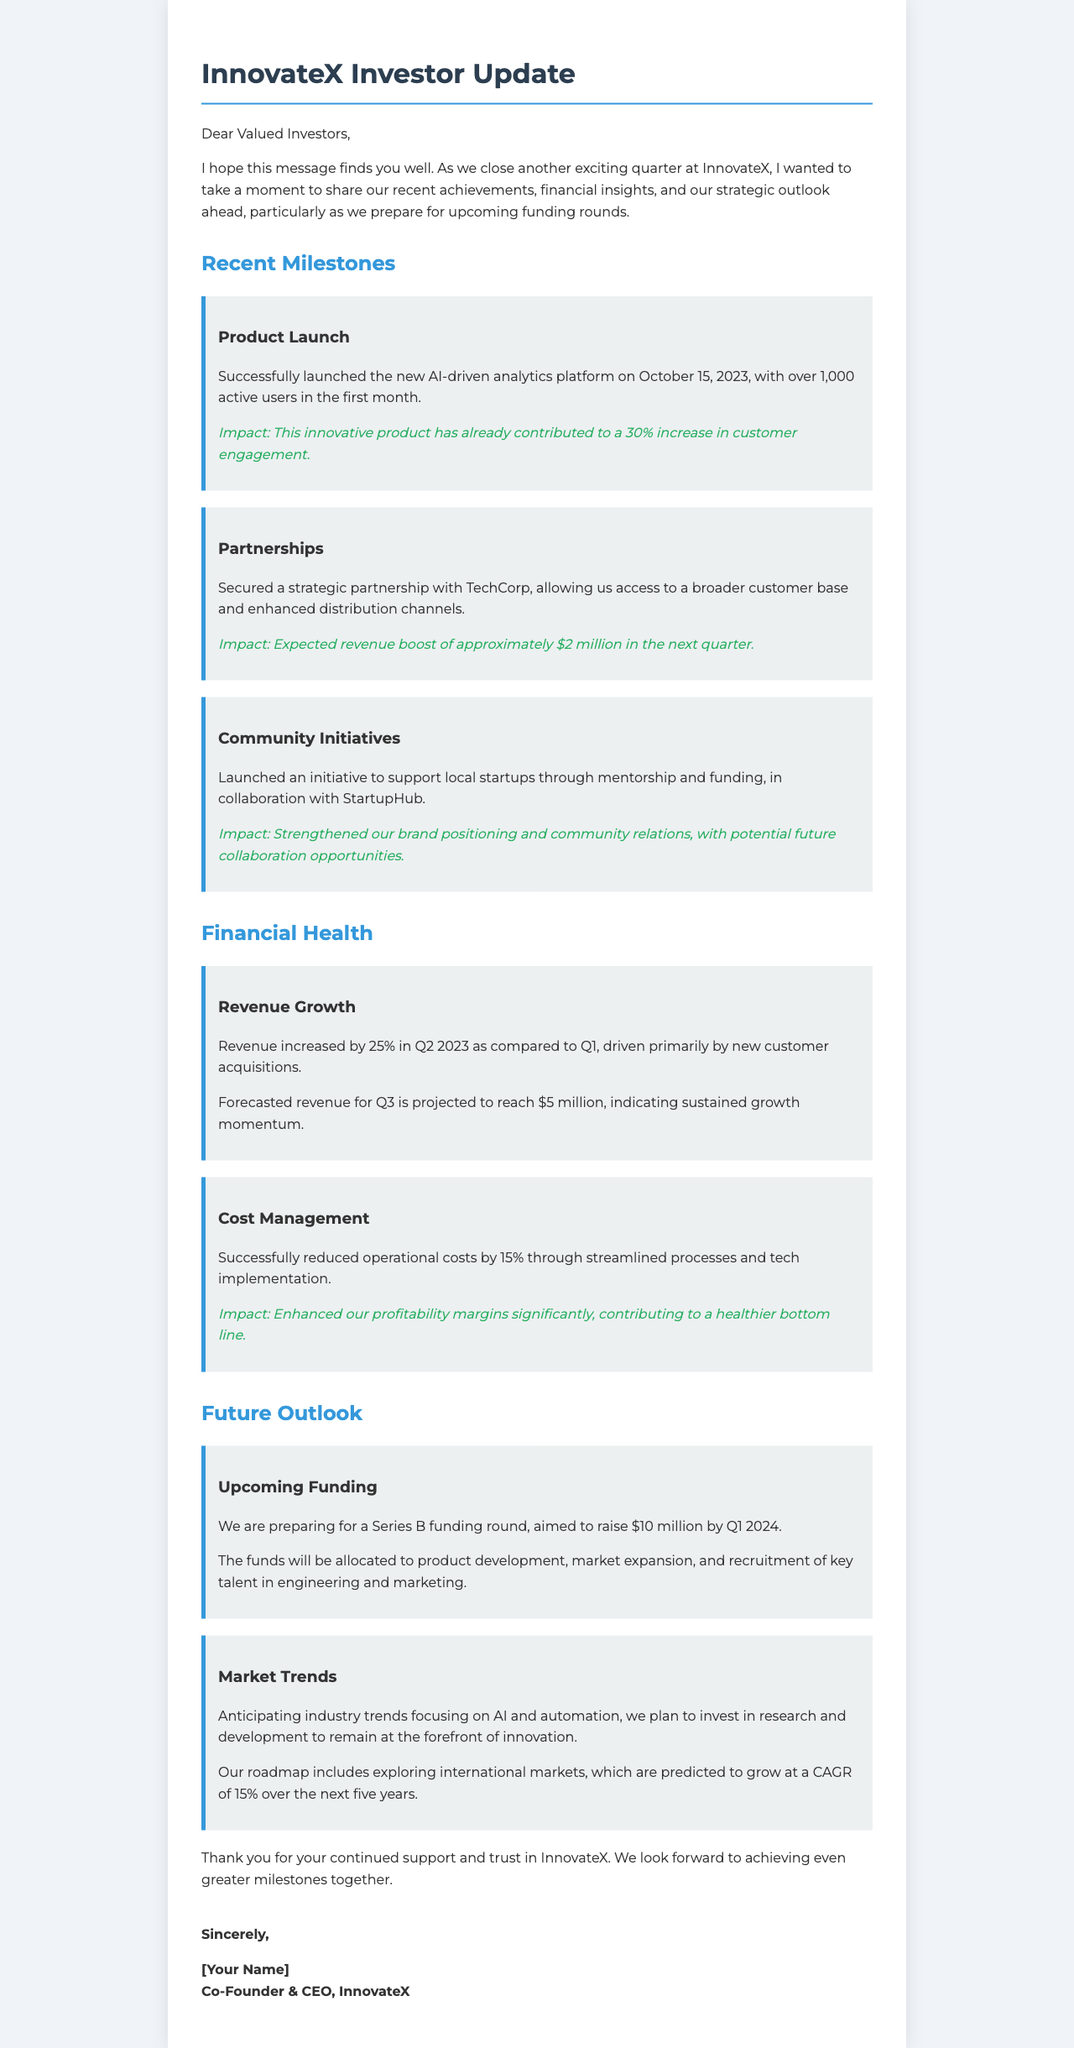what is the new product launched? The document specifies that the new product launched is an AI-driven analytics platform.
Answer: AI-driven analytics platform when was the product launched? The letter mentions that the product was launched on October 15, 2023.
Answer: October 15, 2023 what is the expected revenue boost from the partnership with TechCorp? The document details that the expected revenue boost is approximately $2 million in the next quarter.
Answer: $2 million what is the projected revenue for Q3 2023? The letter states that the forecasted revenue for Q3 2023 is projected to reach $5 million.
Answer: $5 million how much operational costs were reduced? The financial section indicates that operational costs were successfully reduced by 15%.
Answer: 15% what is the target amount for the Series B funding round? The document notes that the Series B funding round aims to raise $10 million.
Answer: $10 million what will the funds from the upcoming funding be allocated to? The letter specifies that funds will be allocated to product development, market expansion, and recruitment of key talent.
Answer: product development, market expansion, and recruitment of key talent which market trends are anticipated? The document highlights anticipating industry trends focusing on AI and automation.
Answer: AI and automation what is the estimated CAGR for international markets over the next five years? The outlook section mentions that the predicted CAGR for international markets is 15%.
Answer: 15% 